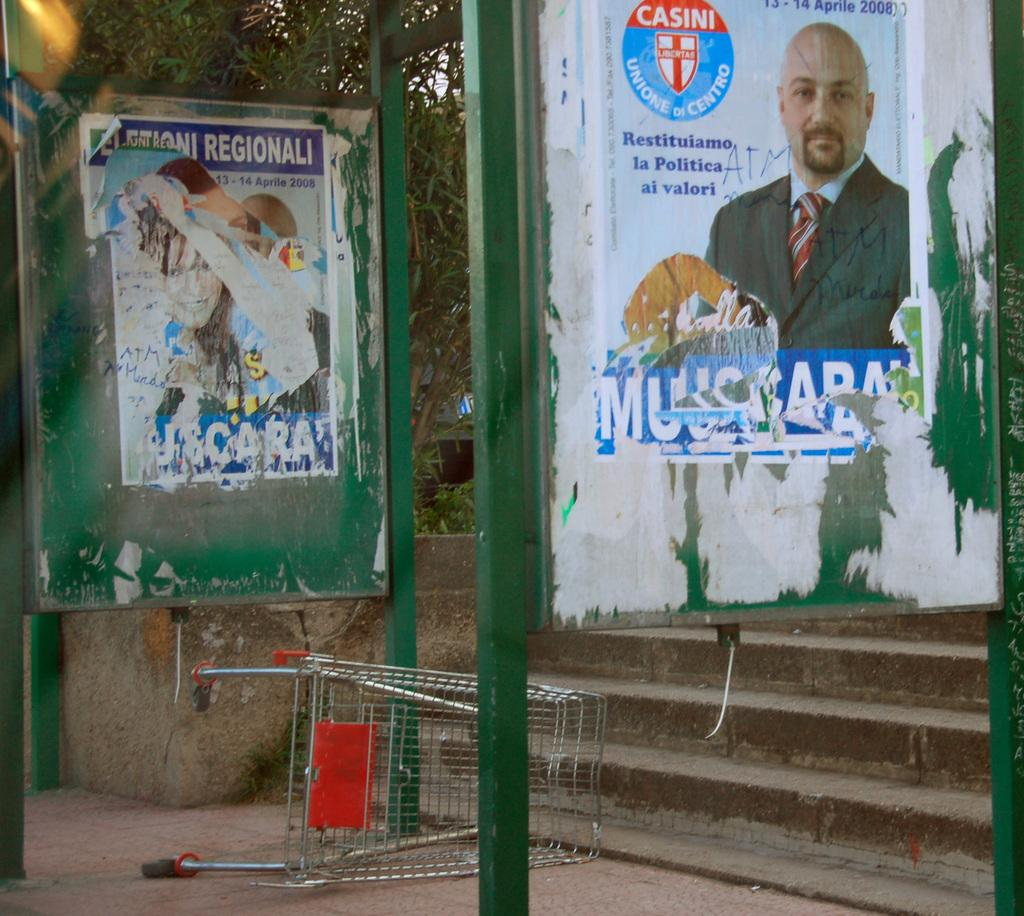<image>
Summarize the visual content of the image. the name Casini is on the poster that is outside 